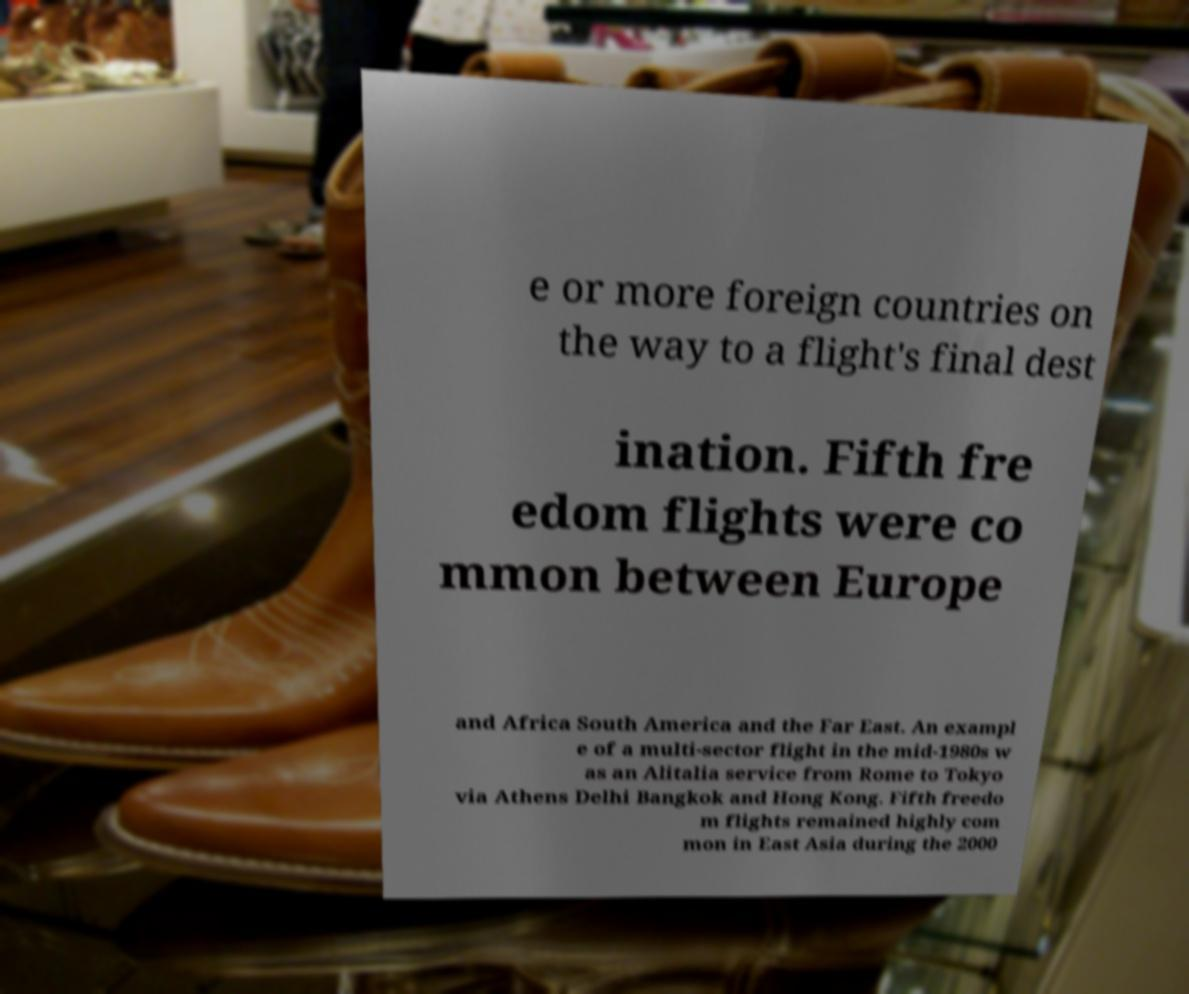For documentation purposes, I need the text within this image transcribed. Could you provide that? e or more foreign countries on the way to a flight's final dest ination. Fifth fre edom flights were co mmon between Europe and Africa South America and the Far East. An exampl e of a multi-sector flight in the mid-1980s w as an Alitalia service from Rome to Tokyo via Athens Delhi Bangkok and Hong Kong. Fifth freedo m flights remained highly com mon in East Asia during the 2000 